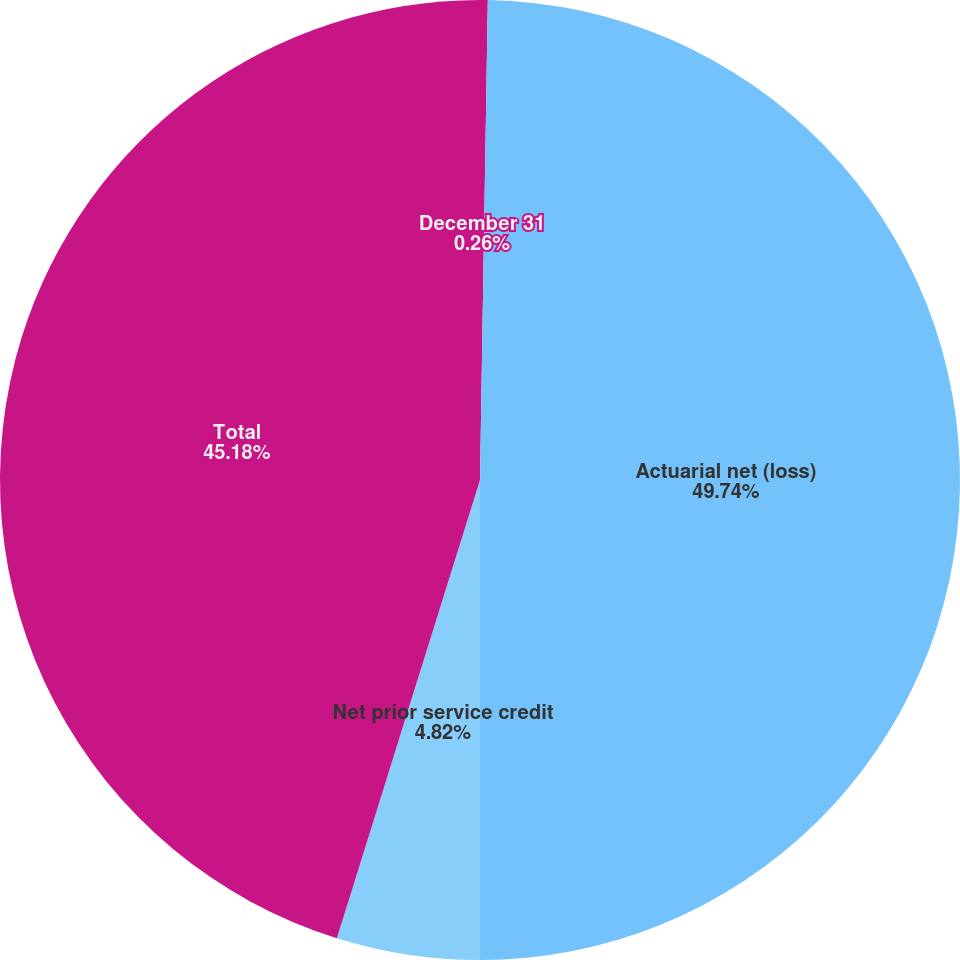Convert chart. <chart><loc_0><loc_0><loc_500><loc_500><pie_chart><fcel>December 31<fcel>Actuarial net (loss)<fcel>Net prior service credit<fcel>Total<nl><fcel>0.26%<fcel>49.74%<fcel>4.82%<fcel>45.18%<nl></chart> 